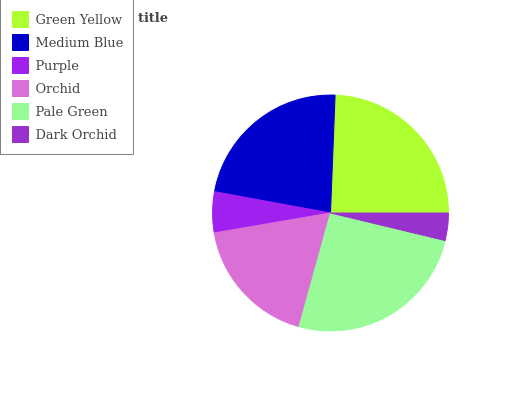Is Dark Orchid the minimum?
Answer yes or no. Yes. Is Pale Green the maximum?
Answer yes or no. Yes. Is Medium Blue the minimum?
Answer yes or no. No. Is Medium Blue the maximum?
Answer yes or no. No. Is Green Yellow greater than Medium Blue?
Answer yes or no. Yes. Is Medium Blue less than Green Yellow?
Answer yes or no. Yes. Is Medium Blue greater than Green Yellow?
Answer yes or no. No. Is Green Yellow less than Medium Blue?
Answer yes or no. No. Is Medium Blue the high median?
Answer yes or no. Yes. Is Orchid the low median?
Answer yes or no. Yes. Is Green Yellow the high median?
Answer yes or no. No. Is Green Yellow the low median?
Answer yes or no. No. 